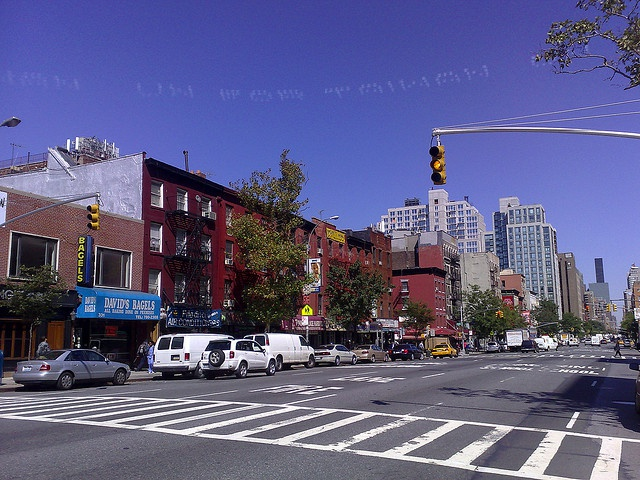Describe the objects in this image and their specific colors. I can see car in blue, black, and gray tones, car in blue, black, lavender, gray, and darkgray tones, truck in blue, lavender, black, darkgray, and gray tones, truck in blue, lavender, black, darkgray, and gray tones, and car in blue, black, darkgray, gray, and lightgray tones in this image. 